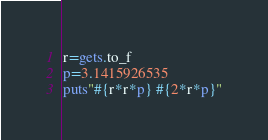Convert code to text. <code><loc_0><loc_0><loc_500><loc_500><_Ruby_>r=gets.to_f
p=3.1415926535
puts"#{r*r*p} #{2*r*p}"</code> 